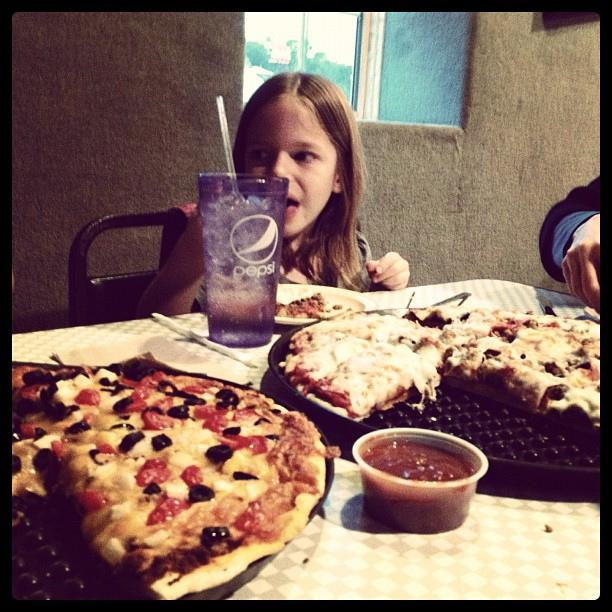What sort of sauce is found in the plastic cup? Please explain your reasoning. marinara. Marinara is provided for dipping. 